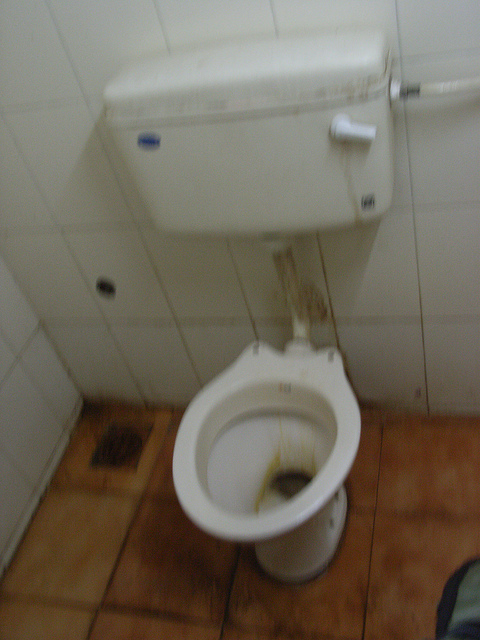<image>Where is the trashcan? There is no trashcan in the image. However, it can be next to the toilet or behind it. Where is the trashcan? The trashcan is not seen in the image. 